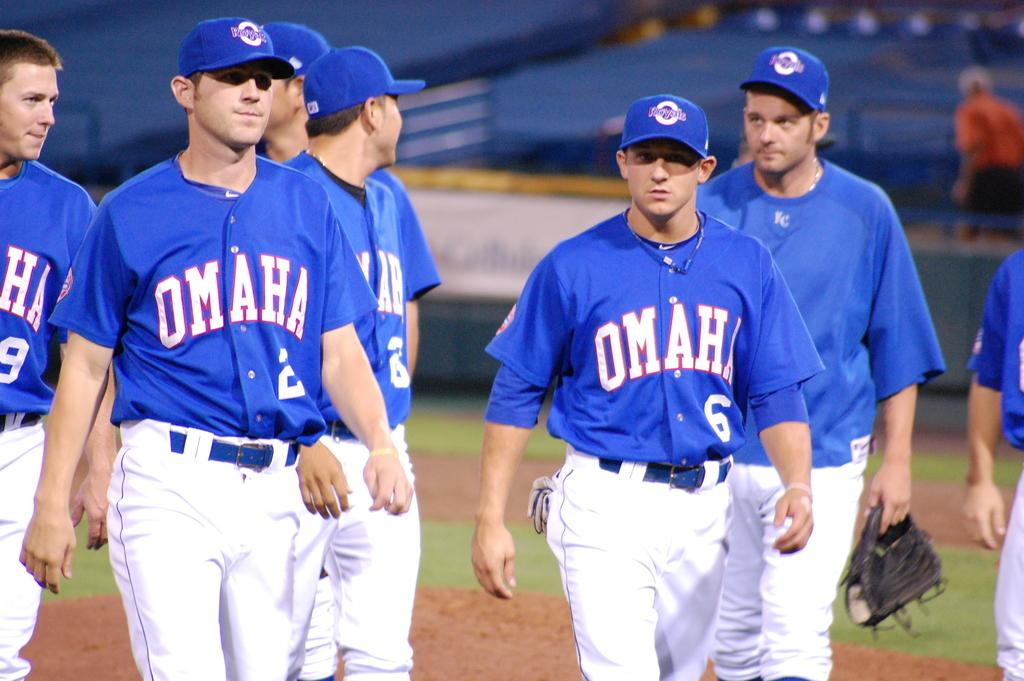<image>
Describe the image concisely. Several baseball players from the Omaha team are walking on the field. 